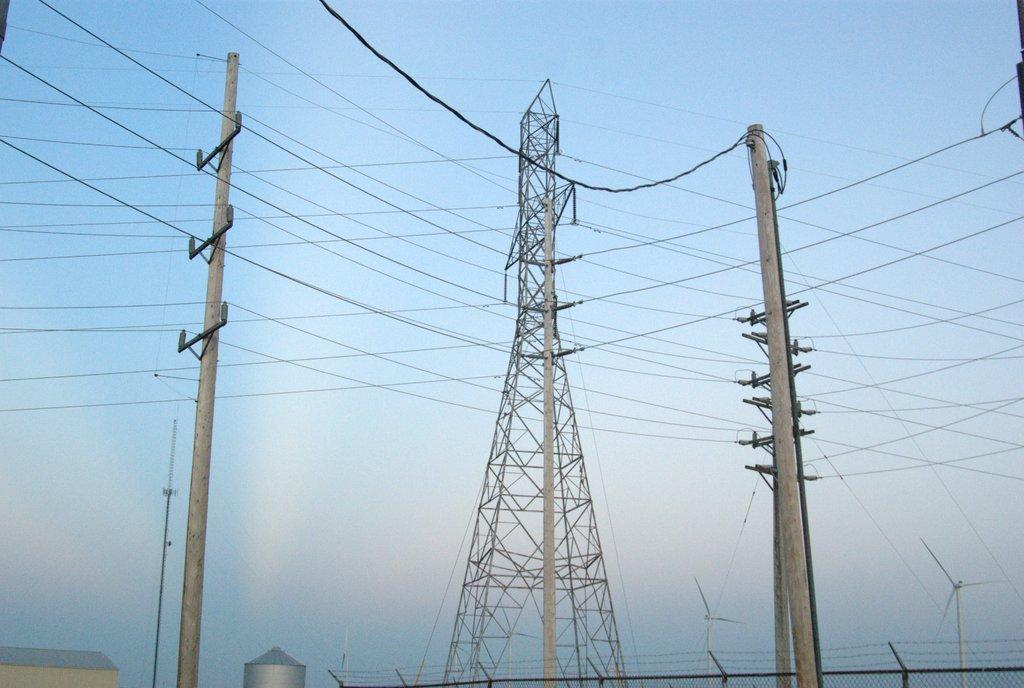What is the main structure in the image? There is a tower in the image. What other objects can be seen in the image? There are two electric poles with wires in the image, and the wires are connected to the tower. What can be seen in the background of the image? There are wind mills and the sky visible in the background of the image. What type of hearing aid is the manager wearing in the image? There is no manager or hearing aid present in the image. How does the heat affect the wind mills in the image? There is no mention of heat in the image, and the wind mills are not affected by any heat. 